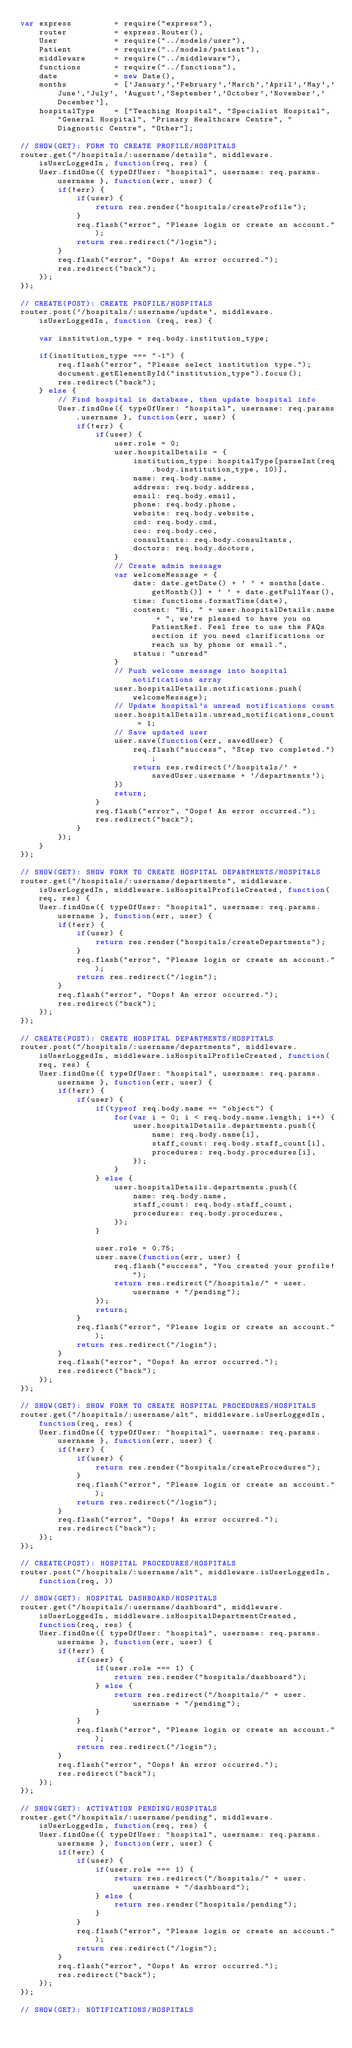Convert code to text. <code><loc_0><loc_0><loc_500><loc_500><_JavaScript_>var express         = require("express"),
    router          = express.Router(),
    User            = require("../models/user"),
    Patient         = require("../models/patient"),
    middleware      = require("../middleware"),
    functions       = require("../functions"),
    date            = new Date(),
    months          = ['January','February','March','April','May','June','July', 'August','September','October','November','December'],
    hospitalType    = ["Teaching Hospital", "Specialist Hospital", "General Hospital", "Primary Healthcare Centre", "Diagnostic Centre", "Other"];

// SHOW(GET): FORM TO CREATE PROFILE/HOSPITALS
router.get("/hospitals/:username/details", middleware.isUserLoggedIn, function(req, res) {
    User.findOne({ typeOfUser: "hospital", username: req.params.username }, function(err, user) {
        if(!err) {
            if(user) {
                return res.render("hospitals/createProfile");
            }
            req.flash("error", "Please login or create an account.");
            return res.redirect("/login");
        }
        req.flash("error", "Oops! An error occurred.");
        res.redirect("back");
    });
});

// CREATE(POST): CREATE PROFILE/HOSPITALS
router.post('/hospitals/:username/update', middleware.isUserLoggedIn, function (req, res) {
    
    var institution_type = req.body.institution_type;

    if(institution_type === "-1") {
        req.flash("error", "Please select institution type.");
        document.getElementById("institution_type").focus();
        res.redirect("back");
    } else {
        // Find hospital in database, then update hospital info
        User.findOne({ typeOfUser: "hospital", username: req.params.username }, function(err, user) {
            if(!err) {
                if(user) {
                    user.role = 0;
                    user.hospitalDetails = {
                        institution_type: hospitalType[parseInt(req.body.institution_type, 10)],
                        name: req.body.name,
                        address: req.body.address,
                        email: req.body.email,
                        phone: req.body.phone,
                        website: req.body.website,
                        cmd: req.body.cmd,
                        ceo: req.body.ceo,
                        consultants: req.body.consultants,
                        doctors: req.body.doctors,
                    }
                    // Create admin message
                    var welcomeMessage = {
                        date: date.getDate() + ' ' + months[date.getMonth()] + ' ' + date.getFullYear(),
                        time: functions.formatTime(date),
                        content: "Hi, " + user.hospitalDetails.name + ", we're pleased to have you on PatientRef. Feel free to use the FAQs section if you need clarifications or reach us by phone or email.",
                        status: "unread"
                    }
                    // Push welcome message into hospital notifications array
                    user.hospitalDetails.notifications.push(welcomeMessage);
                    // Update hospital's unread notifications count
                    user.hospitalDetails.unread_notifications_count = 1;
                    // Save updated user
                    user.save(function(err, savedUser) {
                        req.flash("success", "Step two completed.");
                        return res.redirect('/hospitals/' + savedUser.username + '/departments');
                    })
                    return;
                }
                req.flash("error", "Oops! An error occurred.");
                res.redirect("back");
            }
        });
    }
});

// SHOW(GET): SHOW FORM TO CREATE HOSPITAL DEPARTMENTS/HOSPITALS
router.get("/hospitals/:username/departments", middleware.isUserLoggedIn, middleware.isHospitalProfileCreated, function(req, res) {
    User.findOne({ typeOfUser: "hospital", username: req.params.username }, function(err, user) {
        if(!err) {
            if(user) {
                return res.render("hospitals/createDepartments");
            }
            req.flash("error", "Please login or create an account.");
            return res.redirect("/login");
        }
        req.flash("error", "Oops! An error occurred.");
        res.redirect("back");
    });
});

// CREATE(POST): CREATE HOSPITAL DEPARTMENTS/HOSPITALS
router.post("/hospitals/:username/departments", middleware.isUserLoggedIn, middleware.isHospitalProfileCreated, function(req, res) {
    User.findOne({ typeOfUser: "hospital", username: req.params.username }, function(err, user) {
        if(!err) {
            if(user) {
                if(typeof req.body.name == "object") {
                    for(var i = 0; i < req.body.name.length; i++) {
                        user.hospitalDetails.departments.push({
                            name: req.body.name[i],
                            staff_count: req.body.staff_count[i],
                            procedures: req.body.procedures[i],
                        });
                    }
                } else {
                    user.hospitalDetails.departments.push({
                        name: req.body.name,
                        staff_count: req.body.staff_count,
                        procedures: req.body.procedures,
                    });
                }

                user.role = 0.75;
                user.save(function(err, user) {
                    req.flash("success", "You created your profile!");
                    return res.redirect("/hospitals/" + user.username + "/pending");
                });
                return;
            }
            req.flash("error", "Please login or create an account.");
            return res.redirect("/login");
        }
        req.flash("error", "Oops! An error occurred.");
        res.redirect("back");
    });
});

// SHOW(GET): SHOW FORM TO CREATE HOSPITAL PROCEDURES/HOSPITALS
router.get("/hospitals/:username/alt", middleware.isUserLoggedIn, function(req, res) {
    User.findOne({ typeOfUser: "hospital", username: req.params.username }, function(err, user) {
        if(!err) {
            if(user) {
                return res.render("hospitals/createProcedures");
            }
            req.flash("error", "Please login or create an account.");
            return res.redirect("/login");
        }
        req.flash("error", "Oops! An error occurred.");
        res.redirect("back");
    });
});

// CREATE(POST): HOSPITAL PROCEDURES/HOSPITALS
router.post("/hospitals/:username/alt", middleware.isUserLoggedIn, function(req, ))

// SHOW(GET): HOSPITAL DASHBOARD/HOSPITALS
router.get("/hospitals/:username/dashboard", middleware.isUserLoggedIn, middleware.isHospitalDepartmentCreated, function(req, res) {
    User.findOne({ typeOfUser: "hospital", username: req.params.username }, function(err, user) {
        if(!err) {
            if(user) {
                if(user.role === 1) {
                    return res.render("hospitals/dashboard");
                } else {
                    return res.redirect("/hospitals/" + user.username + "/pending");
                }
            }
            req.flash("error", "Please login or create an account.");
            return res.redirect("/login");
        }
        req.flash("error", "Oops! An error occurred.");
        res.redirect("back");
    });
});

// SHOW(GET): ACTIVATION PENDING/HOSPITALS
router.get("/hospitals/:username/pending", middleware.isUserLoggedIn, function(req, res) {
    User.findOne({ typeOfUser: "hospital", username: req.params.username }, function(err, user) {
        if(!err) {
            if(user) {
                if(user.role === 1) {
                    return res.redirect("/hospitals/" + user.username + "/dashboard");
                } else {
                    return res.render("hospitals/pending");
                }
            }
            req.flash("error", "Please login or create an account.");
            return res.redirect("/login");
        }
        req.flash("error", "Oops! An error occurred.");
        res.redirect("back");
    });
});

// SHOW(GET): NOTIFICATIONS/HOSPITALS</code> 